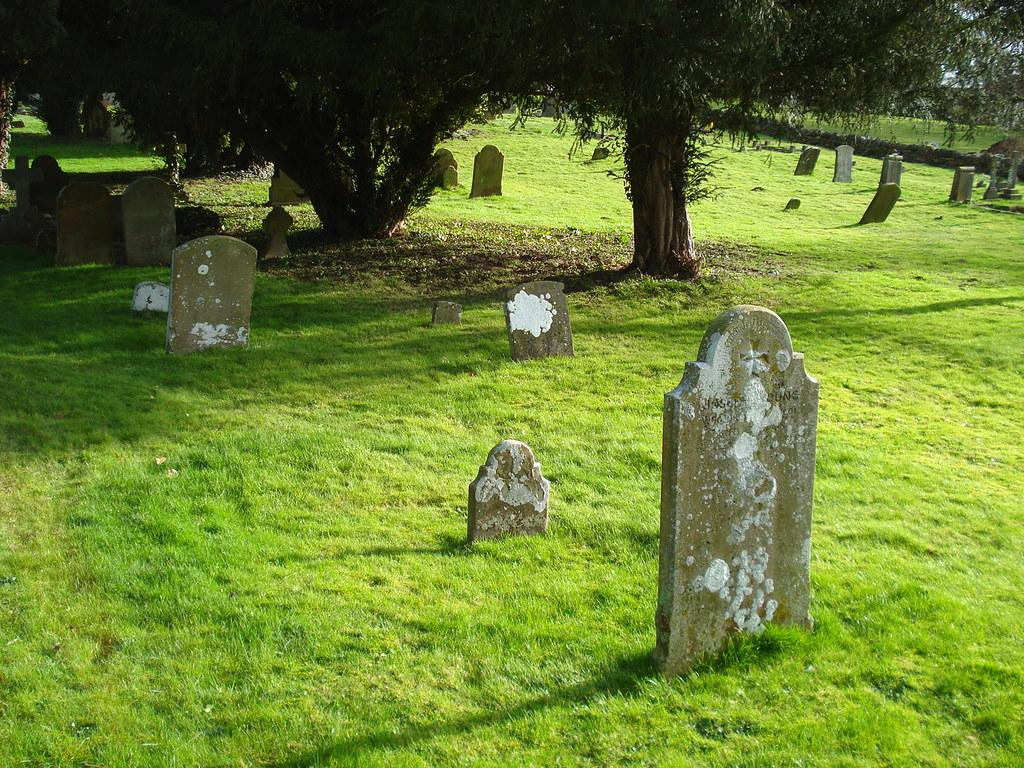What type of vegetation is on the right side of the image? There are trees on the right side of the image. What can be found on the right side of the image along with the trees? There is a memorial on the right side of the image. Can you describe the memorial in the background of the image? There is a memorial visible in the background of the image. What else can be seen in the background of the image? There are trees in the background of the image. What type of quilt is draped over the memorial in the image? There is no quilt present in the image; it features trees and a memorial. How does the concept of peace relate to the image? The image does not explicitly reference or depict the concept of peace, so it cannot be directly related to the image. 